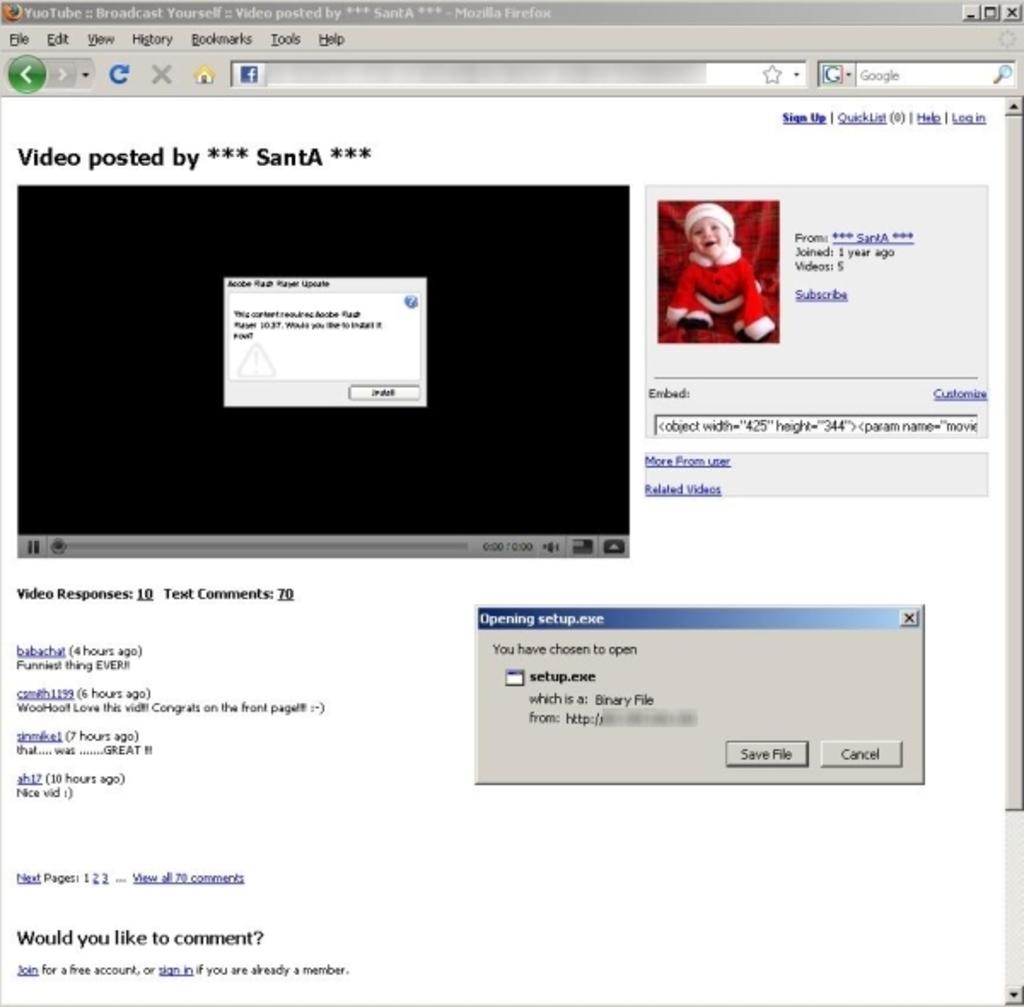This video has been posted by who?
Your response must be concise. Santa. What has been chosen to open?
Your answer should be compact. Setup.exe. 